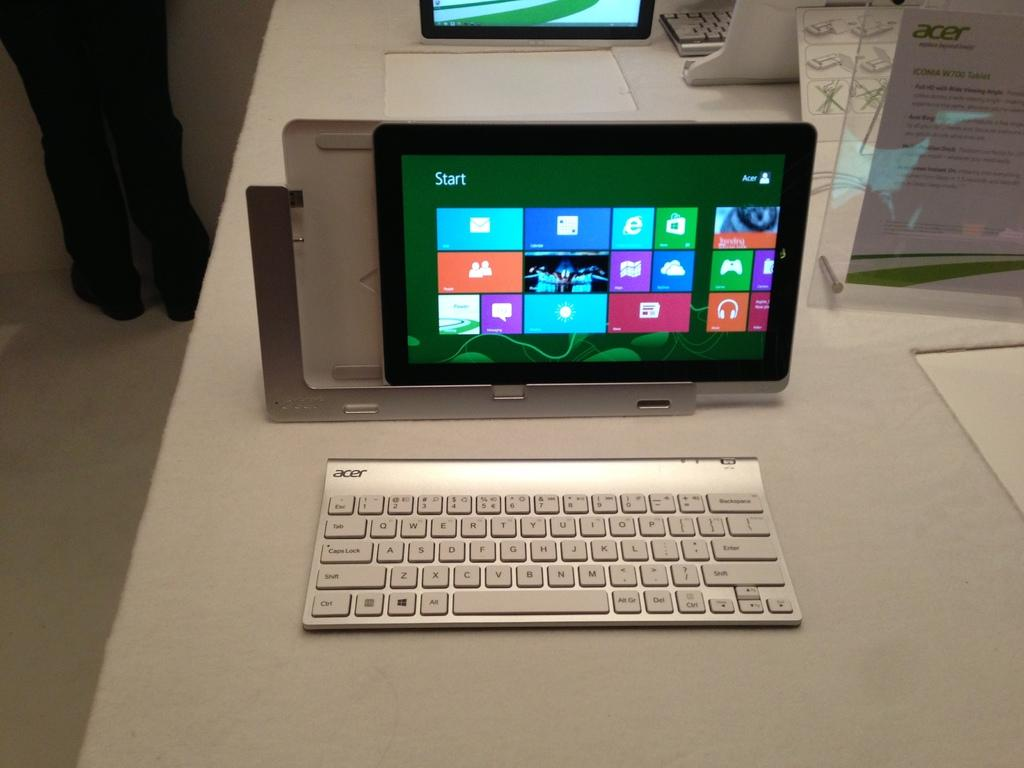How many iPads are visible in the image? There are two iPads in the image. What other electronic devices can be seen in the image? There are two keyboards in the image. What type of object is displayed in a glass frame in the image? There is a paper in a glass frame in the image. Can you describe the person in the image? There is a person standing in the image. Is there a horse visible in the image? No, there is no horse present in the image. What type of object might be used to protect against rain in the image? There is no umbrella present in the image. 